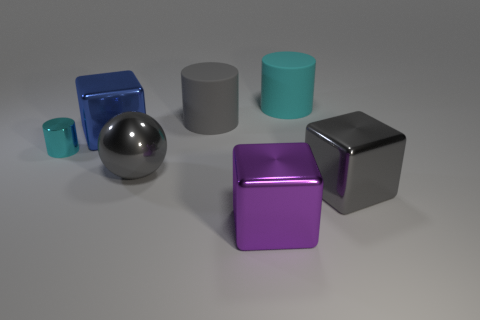Subtract all yellow cubes. Subtract all red cylinders. How many cubes are left? 3 Add 2 metal balls. How many objects exist? 9 Subtract all cylinders. How many objects are left? 4 Add 6 red cylinders. How many red cylinders exist? 6 Subtract 0 blue cylinders. How many objects are left? 7 Subtract all tiny purple rubber cylinders. Subtract all big cyan rubber things. How many objects are left? 6 Add 5 metal things. How many metal things are left? 10 